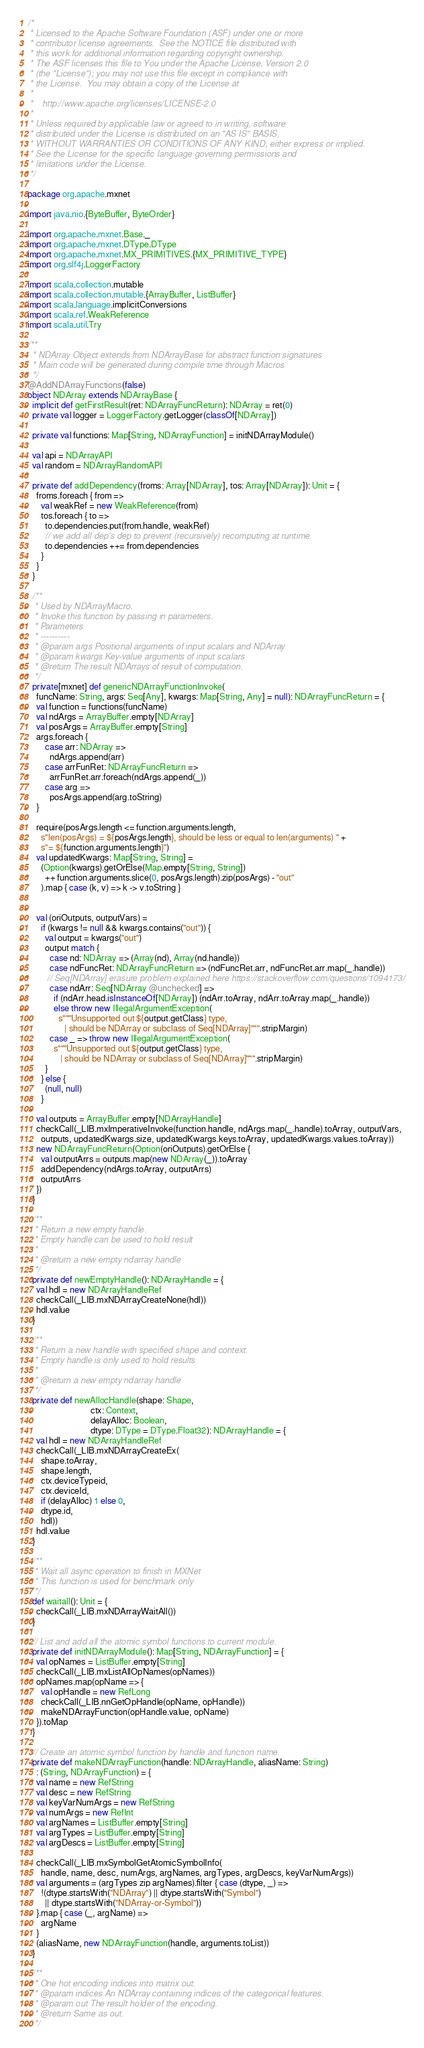<code> <loc_0><loc_0><loc_500><loc_500><_Scala_>/*
 * Licensed to the Apache Software Foundation (ASF) under one or more
 * contributor license agreements.  See the NOTICE file distributed with
 * this work for additional information regarding copyright ownership.
 * The ASF licenses this file to You under the Apache License, Version 2.0
 * (the "License"); you may not use this file except in compliance with
 * the License.  You may obtain a copy of the License at
 *
 *    http://www.apache.org/licenses/LICENSE-2.0
 *
 * Unless required by applicable law or agreed to in writing, software
 * distributed under the License is distributed on an "AS IS" BASIS,
 * WITHOUT WARRANTIES OR CONDITIONS OF ANY KIND, either express or implied.
 * See the License for the specific language governing permissions and
 * limitations under the License.
 */

package org.apache.mxnet

import java.nio.{ByteBuffer, ByteOrder}

import org.apache.mxnet.Base._
import org.apache.mxnet.DType.DType
import org.apache.mxnet.MX_PRIMITIVES.{MX_PRIMITIVE_TYPE}
import org.slf4j.LoggerFactory

import scala.collection.mutable
import scala.collection.mutable.{ArrayBuffer, ListBuffer}
import scala.language.implicitConversions
import scala.ref.WeakReference
import scala.util.Try

/**
  * NDArray Object extends from NDArrayBase for abstract function signatures
  * Main code will be generated during compile time through Macros
  */
@AddNDArrayFunctions(false)
object NDArray extends NDArrayBase {
  implicit def getFirstResult(ret: NDArrayFuncReturn): NDArray = ret(0)
  private val logger = LoggerFactory.getLogger(classOf[NDArray])

  private val functions: Map[String, NDArrayFunction] = initNDArrayModule()

  val api = NDArrayAPI
  val random = NDArrayRandomAPI

  private def addDependency(froms: Array[NDArray], tos: Array[NDArray]): Unit = {
    froms.foreach { from =>
      val weakRef = new WeakReference(from)
      tos.foreach { to =>
        to.dependencies.put(from.handle, weakRef)
        // we add all dep's dep to prevent (recursively) recomputing at runtime.
        to.dependencies ++= from.dependencies
      }
    }
  }

  /**
   * Used by NDArrayMacro.
   * Invoke this function by passing in parameters.
   * Parameters
   * ----------
   * @param args Positional arguments of input scalars and NDArray
   * @param kwargs Key-value arguments of input scalars
   * @return The result NDArrays of result of computation.
   */
  private[mxnet] def genericNDArrayFunctionInvoke(
    funcName: String, args: Seq[Any], kwargs: Map[String, Any] = null): NDArrayFuncReturn = {
    val function = functions(funcName)
    val ndArgs = ArrayBuffer.empty[NDArray]
    val posArgs = ArrayBuffer.empty[String]
    args.foreach {
        case arr: NDArray =>
          ndArgs.append(arr)
        case arrFunRet: NDArrayFuncReturn =>
          arrFunRet.arr.foreach(ndArgs.append(_))
        case arg =>
          posArgs.append(arg.toString)
    }

    require(posArgs.length <= function.arguments.length,
      s"len(posArgs) = ${posArgs.length}, should be less or equal to len(arguments) " +
      s"= ${function.arguments.length}")
    val updatedKwargs: Map[String, String] =
      (Option(kwargs).getOrElse(Map.empty[String, String])
        ++ function.arguments.slice(0, posArgs.length).zip(posArgs) - "out"
      ).map { case (k, v) => k -> v.toString }


    val (oriOutputs, outputVars) =
      if (kwargs != null && kwargs.contains("out")) {
        val output = kwargs("out")
        output match {
          case nd: NDArray => (Array(nd), Array(nd.handle))
          case ndFuncRet: NDArrayFuncReturn => (ndFuncRet.arr, ndFuncRet.arr.map(_.handle))
         // Seq[NDArray] erasure problem explained here https://stackoverflow.com/questions/1094173/
          case ndArr: Seq[NDArray @unchecked] =>
            if (ndArr.head.isInstanceOf[NDArray]) (ndArr.toArray, ndArr.toArray.map(_.handle))
            else throw new IllegalArgumentException(
              s"""Unsupported out ${output.getClass} type,
                 | should be NDArray or subclass of Seq[NDArray]""".stripMargin)
          case _ => throw new IllegalArgumentException(
            s"""Unsupported out ${output.getClass} type,
               | should be NDArray or subclass of Seq[NDArray]""".stripMargin)
        }
      } else {
        (null, null)
      }

    val outputs = ArrayBuffer.empty[NDArrayHandle]
    checkCall(_LIB.mxImperativeInvoke(function.handle, ndArgs.map(_.handle).toArray, outputVars,
      outputs, updatedKwargs.size, updatedKwargs.keys.toArray, updatedKwargs.values.toArray))
    new NDArrayFuncReturn(Option(oriOutputs).getOrElse {
      val outputArrs = outputs.map(new NDArray(_)).toArray
      addDependency(ndArgs.toArray, outputArrs)
      outputArrs
    })
  }

  /**
   * Return a new empty handle.
   * Empty handle can be used to hold result
   *
   * @return a new empty ndarray handle
   */
  private def newEmptyHandle(): NDArrayHandle = {
    val hdl = new NDArrayHandleRef
    checkCall(_LIB.mxNDArrayCreateNone(hdl))
    hdl.value
  }

  /**
   * Return a new handle with specified shape and context.
   * Empty handle is only used to hold results
   *
   * @return a new empty ndarray handle
   */
  private def newAllocHandle(shape: Shape,
                             ctx: Context,
                             delayAlloc: Boolean,
                             dtype: DType = DType.Float32): NDArrayHandle = {
    val hdl = new NDArrayHandleRef
    checkCall(_LIB.mxNDArrayCreateEx(
      shape.toArray,
      shape.length,
      ctx.deviceTypeid,
      ctx.deviceId,
      if (delayAlloc) 1 else 0,
      dtype.id,
      hdl))
    hdl.value
  }

  /**
   * Wait all async operation to finish in MXNet
   * This function is used for benchmark only
   */
  def waitall(): Unit = {
    checkCall(_LIB.mxNDArrayWaitAll())
  }

  // List and add all the atomic symbol functions to current module.
  private def initNDArrayModule(): Map[String, NDArrayFunction] = {
    val opNames = ListBuffer.empty[String]
    checkCall(_LIB.mxListAllOpNames(opNames))
    opNames.map(opName => {
      val opHandle = new RefLong
      checkCall(_LIB.nnGetOpHandle(opName, opHandle))
      makeNDArrayFunction(opHandle.value, opName)
    }).toMap
  }

  // Create an atomic symbol function by handle and function name.
  private def makeNDArrayFunction(handle: NDArrayHandle, aliasName: String)
    : (String, NDArrayFunction) = {
    val name = new RefString
    val desc = new RefString
    val keyVarNumArgs = new RefString
    val numArgs = new RefInt
    val argNames = ListBuffer.empty[String]
    val argTypes = ListBuffer.empty[String]
    val argDescs = ListBuffer.empty[String]

    checkCall(_LIB.mxSymbolGetAtomicSymbolInfo(
      handle, name, desc, numArgs, argNames, argTypes, argDescs, keyVarNumArgs))
    val arguments = (argTypes zip argNames).filter { case (dtype, _) =>
      !(dtype.startsWith("NDArray") || dtype.startsWith("Symbol")
        || dtype.startsWith("NDArray-or-Symbol"))
    }.map { case (_, argName) =>
      argName
    }
    (aliasName, new NDArrayFunction(handle, arguments.toList))
  }

  /**
   * One hot encoding indices into matrix out.
   * @param indices An NDArray containing indices of the categorical features.
   * @param out The result holder of the encoding.
   * @return Same as out.
   */</code> 